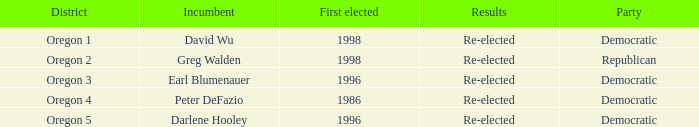Who is the incumbent for the Oregon 5 District that was elected in 1996? Darlene Hooley. Can you parse all the data within this table? {'header': ['District', 'Incumbent', 'First elected', 'Results', 'Party'], 'rows': [['Oregon 1', 'David Wu', '1998', 'Re-elected', 'Democratic'], ['Oregon 2', 'Greg Walden', '1998', 'Re-elected', 'Republican'], ['Oregon 3', 'Earl Blumenauer', '1996', 'Re-elected', 'Democratic'], ['Oregon 4', 'Peter DeFazio', '1986', 'Re-elected', 'Democratic'], ['Oregon 5', 'Darlene Hooley', '1996', 'Re-elected', 'Democratic']]} 